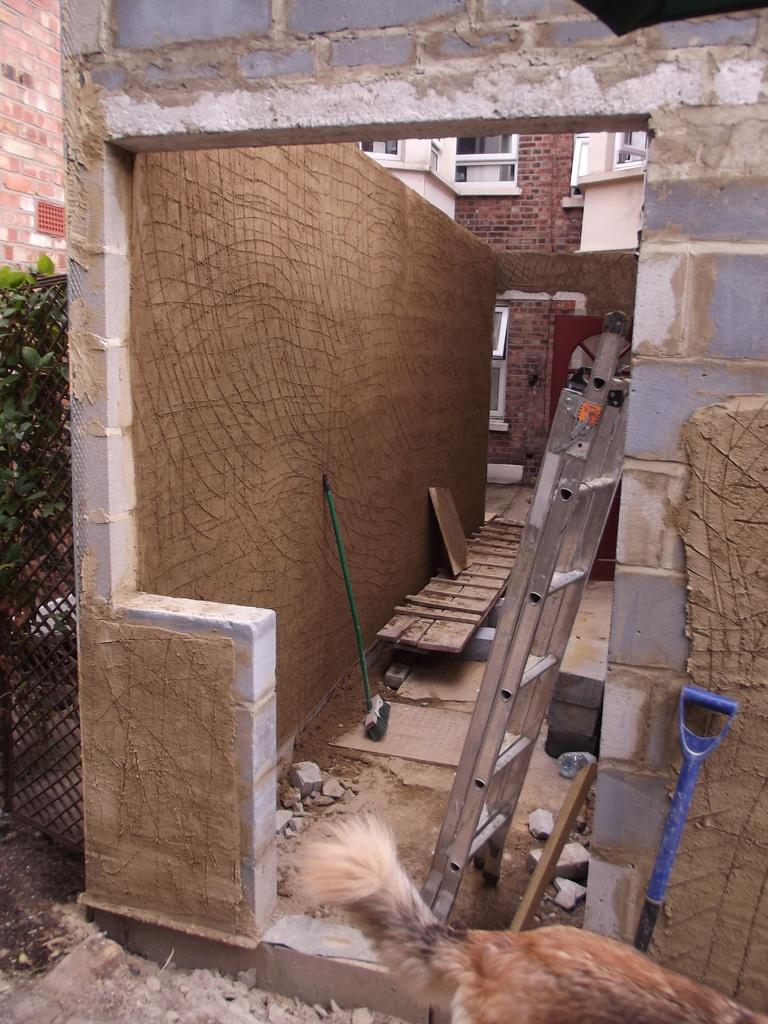Please provide a concise description of this image. On the left we can see fencing, plants and brick wall. In the middle of the picture we can see a place under construction and there are ladder, hammer and various objects. At the bottom there are stones and a dog. In the background there are buildings. 